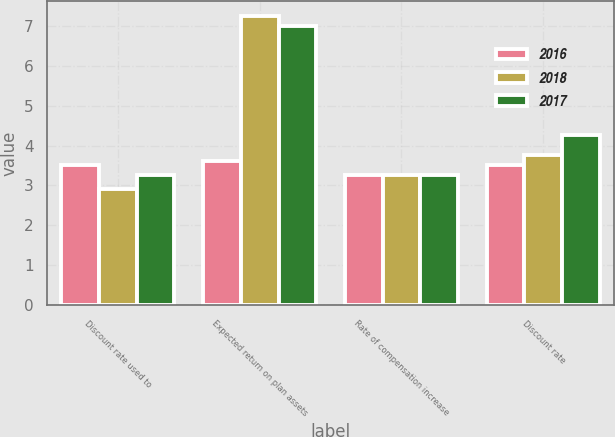<chart> <loc_0><loc_0><loc_500><loc_500><stacked_bar_chart><ecel><fcel>Discount rate used to<fcel>Expected return on plan assets<fcel>Rate of compensation increase<fcel>Discount rate<nl><fcel>2016<fcel>3.5<fcel>3.625<fcel>3.25<fcel>3.5<nl><fcel>2018<fcel>2.9<fcel>7.25<fcel>3.25<fcel>3.76<nl><fcel>2017<fcel>3.25<fcel>7<fcel>3.25<fcel>4.26<nl></chart> 